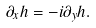<formula> <loc_0><loc_0><loc_500><loc_500>\partial _ { x } h = - i \partial _ { y } h .</formula> 